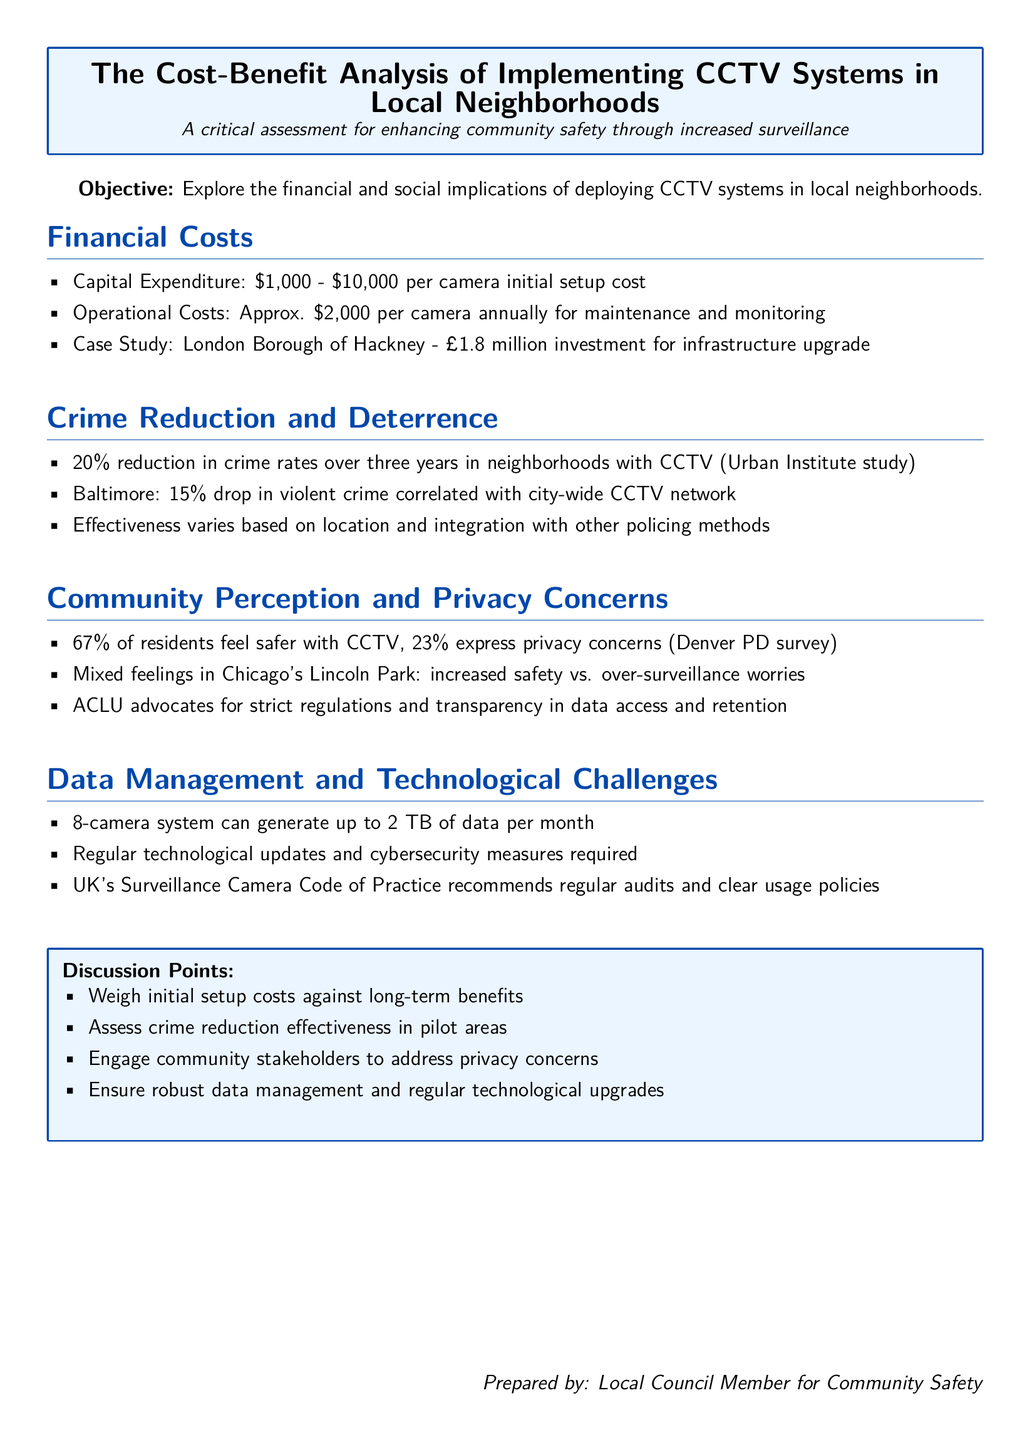What is the initial setup cost range for CCTV cameras? The document states the initial setup cost for CCTV cameras ranges from \$1,000 to \$10,000.
Answer: \$1,000 - \$10,000 What is the annual operational cost per camera? According to the document, the operational costs per camera amount to approximately \$2,000 annually.
Answer: \$2,000 What percentage of residents feel safer with CCTV? The Denver PD survey mentioned in the document shows that 67% of residents feel safer with CCTV systems in place.
Answer: 67% What was the crime rate reduction observed in neighborhoods with CCTV according to the Urban Institute study? The document notes a 20% reduction in crime rates over three years in neighborhoods with CCTV, according to the Urban Institute study.
Answer: 20% What is the data generation from an 8-camera system per month? The document states that an 8-camera system can generate up to 2 TB of data per month.
Answer: 2 TB What advocacy group emphasizes the need for regulations on data management? The document mentions that the ACLU advocates for strict regulations and transparency in data access and retention.
Answer: ACLU How much was invested in the infrastructure upgrade for the London Borough of Hackney? The document states that the investment for the infrastructure upgrade in the London Borough of Hackney was £1.8 million.
Answer: £1.8 million What percentage of residents expressed privacy concerns according to the Denver PD survey? The document indicates that 23% of residents expressed privacy concerns as per the Denver PD survey.
Answer: 23% What type of engagement is recommended to address community privacy concerns? The document suggests engaging community stakeholders to address privacy concerns.
Answer: Engaging community stakeholders 